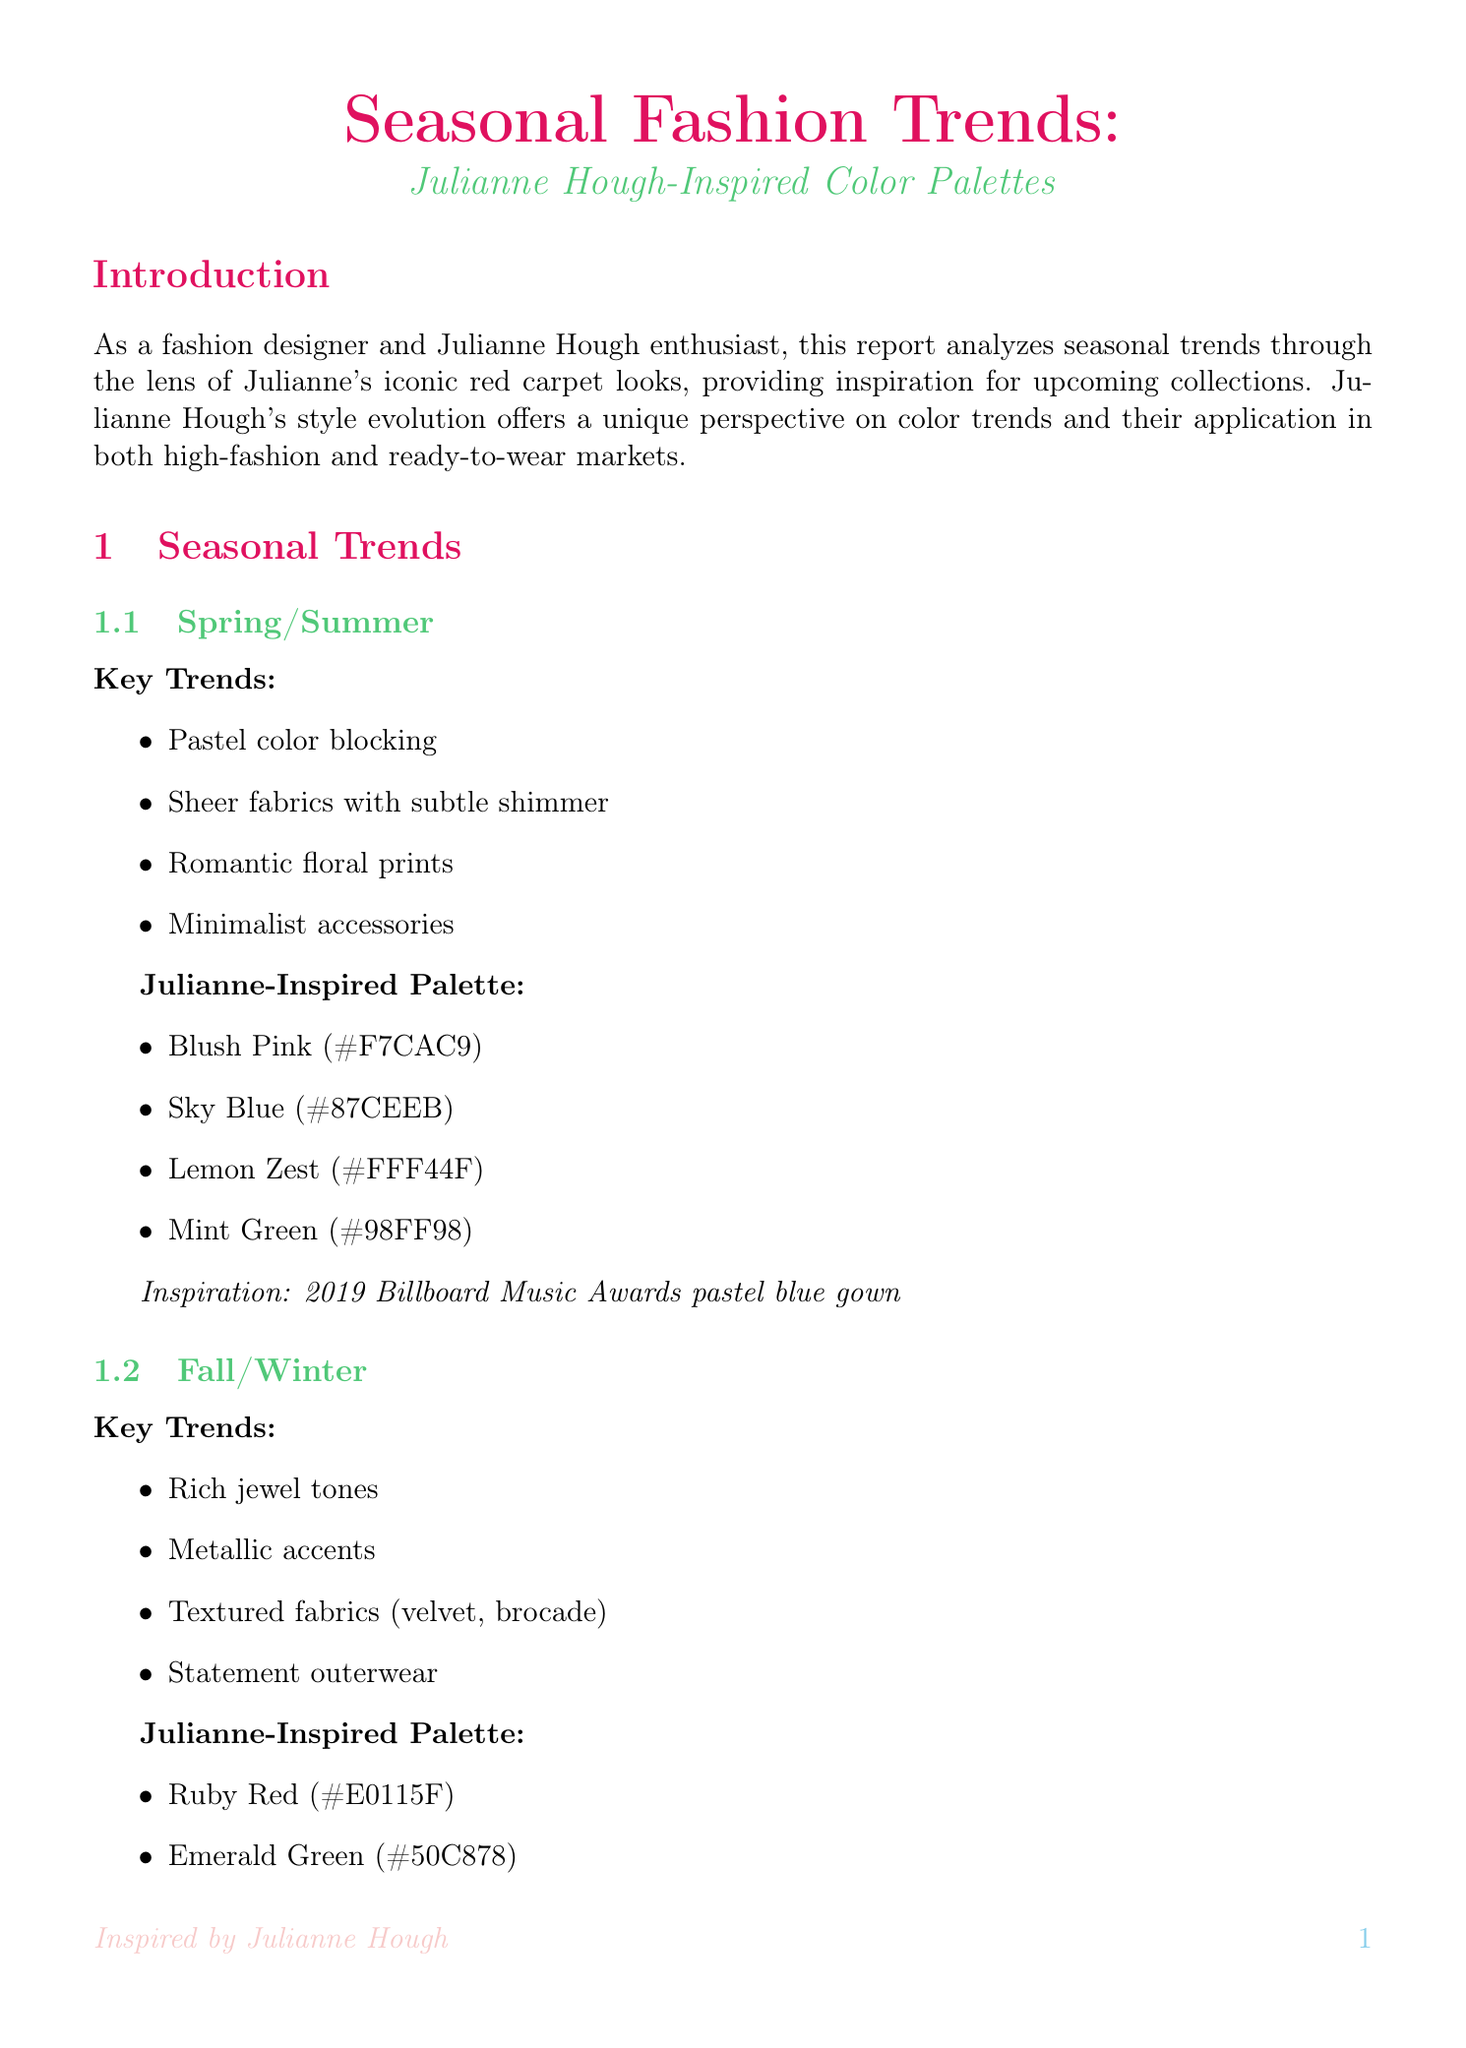What is the title of the report? The title of the report is specifically stated at the beginning of the document.
Answer: Seasonal Fashion Trends: Julianne Hough-Inspired Color Palettes What color palette is inspired by Julianne Hough's 2019 Billboard Music Awards look? The document lists the color palette inspired by the specific inspiration look associated with Spring/Summer.
Answer: Blush Pink, Sky Blue, Lemon Zest, Mint Green Which trend is highlighted for the Fall/Winter season? The key trends for the Fall/Winter season are outlined in the seasonal trends section of the document.
Answer: Rich jewel tones What is the target demographic described in the market analysis? The market analysis section describes the fashion-forward demographic targeted by the fashion line.
Answer: Fashion-forward women aged 25-40 Who is mentioned as a potential partner for collaboration? The collaboration ideas section names potential partners for a capsule collection.
Answer: Julianne Hough What sustainable practice is mentioned in the sustainability section? The sustainability section lists eco-friendly practices associated with the fashion line.
Answer: Use of deadstock fabrics Which fabric is Julianne Hough's favorite for casual wear? The fabric analysis section identifies specific preferences expressed by Julianne Hough.
Answer: Eco-friendly denim What type of footwear is highlighted in the accessory focus? Footwear highlights are listed under the accessory focus section of the document.
Answer: Block heel sandals 